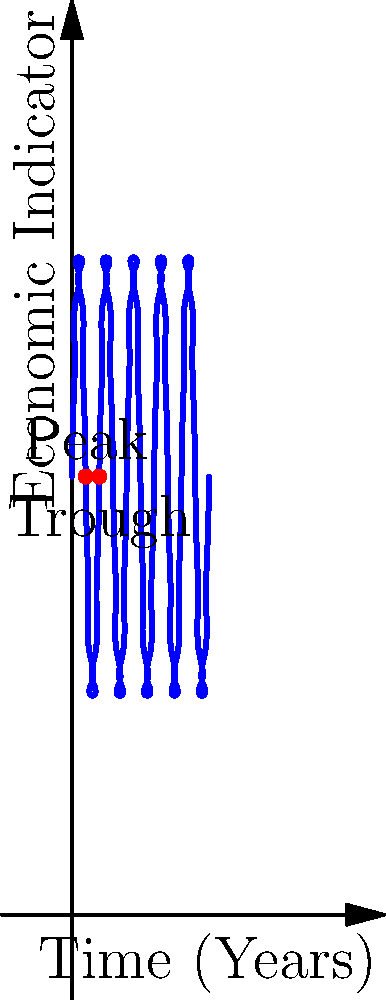The spiral plot above illustrates the cyclical nature of an economic indicator over time. Based on the graph, what is the approximate period of one complete economic cycle in years? To determine the period of one complete economic cycle, we need to follow these steps:

1. Identify the key features of the spiral plot:
   - The spiral expands outward as time progresses.
   - The oscillations represent the cyclical nature of the economic indicator.

2. Locate two consecutive peaks or troughs:
   - We can see a peak labeled on the graph.
   - The next trough is also labeled.

3. Calculate the time difference between these two points:
   - The peak occurs at approximately 2.5 years.
   - The trough occurs at approximately 5 years.

4. Calculate the period:
   - The period is the time between two consecutive peaks or two consecutive troughs.
   - Since we have a peak and a trough, this represents half a cycle.
   - Therefore, the full cycle is twice this distance: $5 - 2.5 = 2.5$ years for half a cycle.
   - Full cycle = $2 \times 2.5 = 5$ years.

5. Verify visually:
   - We can see that the pattern repeats approximately every 5 units on the time axis, confirming our calculation.
Answer: 5 years 